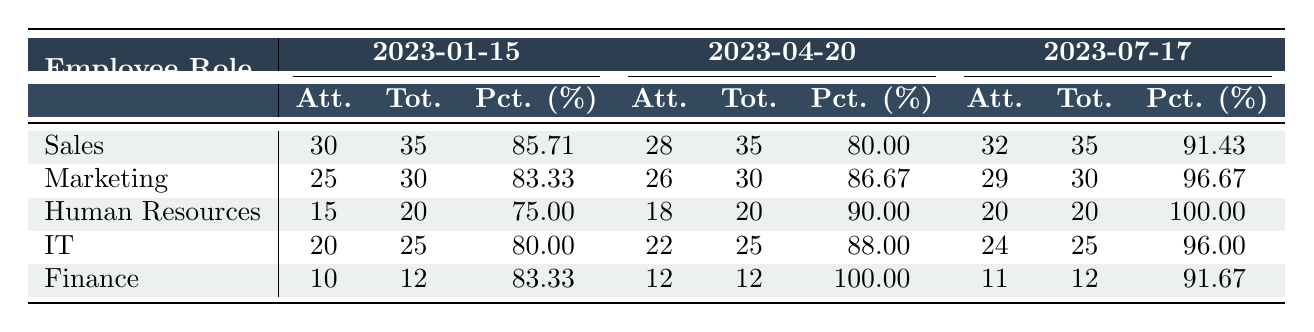What is the attendance percentage for the Human Resources role on 2023-07-17? The table shows that the attendance percentage for Human Resources on that date is listed under the 2023-07-17 column. It is indicated as 100.00%.
Answer: 100.00% How many Sales employees attended the training session on 2023-04-20? Referring to the Sales row and the 2023-04-20 session in the table, the number of attendees is 28.
Answer: 28 Which employee role had the lowest attendance percentage on 2023-01-15? Looking at the first session date (2023-01-15), the attendance percentages for each role are: Sales (85.71%), Marketing (83.33%), Human Resources (75.00%), IT (80.00%), and Finance (83.33%). The lowest percentage is from Human Resources at 75.00%.
Answer: Human Resources What is the average attendance percentage for the IT role across all sessions? The attendance percentages for IT are 80.00%, 88.00%, and 96.00%. To calculate the average: (80.00 + 88.00 + 96.00) / 3 = 88.00.
Answer: 88.00 Did any employee role have a 100% attendance on any session? Checking the data, Human Resources had a 100.00% attendance on 2023-07-17. Thus, the answer is yes.
Answer: Yes Which session date had the highest overall average attendance percentage across all roles? We need to calculate the average attendance percentages for each session: 
- 2023-01-15: (85.71 + 83.33 + 75.00 + 80.00 + 83.33) / 5 = 81.83%
- 2023-04-20: (80.00 + 86.67 + 90.00 + 88.00 + 100.00) / 5 = 89.13%
- 2023-07-17: (91.43 + 96.67 + 100.00 + 96.00 + 91.67) / 5 = 95.15%
The highest average percentage is for 2023-07-17 at 95.15%.
Answer: 2023-07-17 What is the total number of attendees from the Finance role across all sessions? The number of Finance attendees is given in the table: 10 (2023-01-15) + 12 (2023-04-20) + 11 (2023-07-17) = 33.
Answer: 33 Which session had the highest number of attendees from the Marketing role? Looking at the Marketing row, the number of attendees for each session is: 25 (2023-01-15), 26 (2023-04-20), and 29 (2023-07-17). The highest number is 29 on 2023-07-17.
Answer: 2023-07-17 What was the total attendance from all employee roles for the session on 2023-04-20? Adding all attendees for the 2023-04-20 session: 28 (Sales) + 26 (Marketing) + 18 (Human Resources) + 22 (IT) + 12 (Finance) = 106.
Answer: 106 